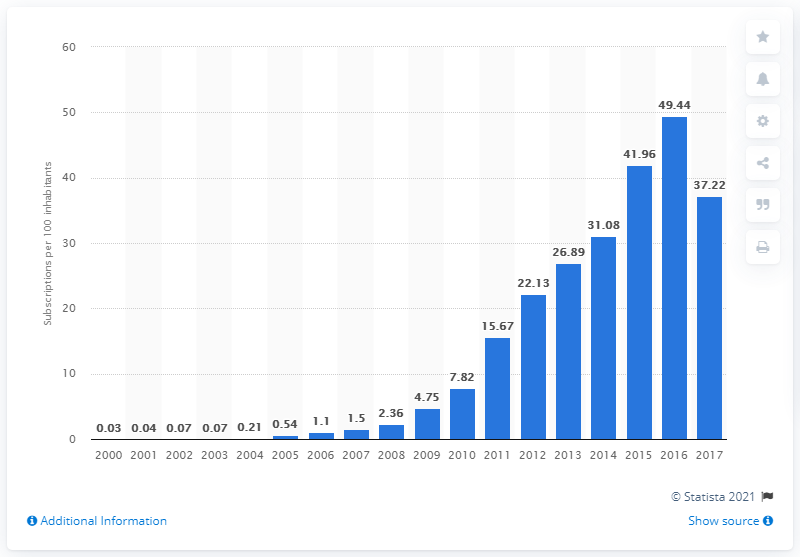Outline some significant characteristics in this image. During the period of 2000 to 2017, there were an average of 37.22 mobile subscriptions registered for every 100 people in Ethiopia. 